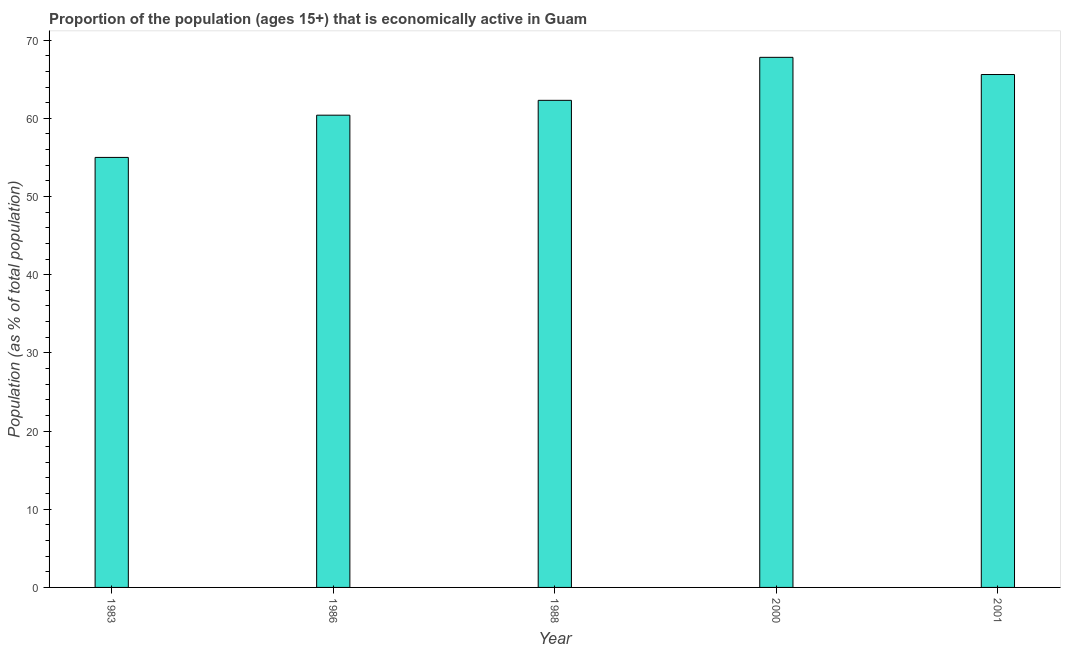Does the graph contain any zero values?
Your answer should be very brief. No. Does the graph contain grids?
Offer a very short reply. No. What is the title of the graph?
Offer a terse response. Proportion of the population (ages 15+) that is economically active in Guam. What is the label or title of the X-axis?
Provide a short and direct response. Year. What is the label or title of the Y-axis?
Provide a short and direct response. Population (as % of total population). What is the percentage of economically active population in 2001?
Provide a succinct answer. 65.6. Across all years, what is the maximum percentage of economically active population?
Ensure brevity in your answer.  67.8. In which year was the percentage of economically active population minimum?
Offer a terse response. 1983. What is the sum of the percentage of economically active population?
Your answer should be compact. 311.1. What is the difference between the percentage of economically active population in 2000 and 2001?
Offer a terse response. 2.2. What is the average percentage of economically active population per year?
Make the answer very short. 62.22. What is the median percentage of economically active population?
Your response must be concise. 62.3. Do a majority of the years between 2000 and 1988 (inclusive) have percentage of economically active population greater than 64 %?
Ensure brevity in your answer.  No. What is the ratio of the percentage of economically active population in 1983 to that in 2000?
Your answer should be compact. 0.81. What is the difference between the highest and the second highest percentage of economically active population?
Ensure brevity in your answer.  2.2. Is the sum of the percentage of economically active population in 2000 and 2001 greater than the maximum percentage of economically active population across all years?
Give a very brief answer. Yes. How many bars are there?
Offer a terse response. 5. Are all the bars in the graph horizontal?
Keep it short and to the point. No. Are the values on the major ticks of Y-axis written in scientific E-notation?
Ensure brevity in your answer.  No. What is the Population (as % of total population) in 1983?
Your response must be concise. 55. What is the Population (as % of total population) in 1986?
Your answer should be compact. 60.4. What is the Population (as % of total population) of 1988?
Offer a very short reply. 62.3. What is the Population (as % of total population) in 2000?
Offer a very short reply. 67.8. What is the Population (as % of total population) of 2001?
Keep it short and to the point. 65.6. What is the difference between the Population (as % of total population) in 1983 and 1986?
Your answer should be very brief. -5.4. What is the difference between the Population (as % of total population) in 1983 and 2000?
Provide a succinct answer. -12.8. What is the difference between the Population (as % of total population) in 1986 and 1988?
Your answer should be compact. -1.9. What is the difference between the Population (as % of total population) in 1986 and 2001?
Ensure brevity in your answer.  -5.2. What is the difference between the Population (as % of total population) in 1988 and 2000?
Keep it short and to the point. -5.5. What is the ratio of the Population (as % of total population) in 1983 to that in 1986?
Your answer should be very brief. 0.91. What is the ratio of the Population (as % of total population) in 1983 to that in 1988?
Your answer should be compact. 0.88. What is the ratio of the Population (as % of total population) in 1983 to that in 2000?
Give a very brief answer. 0.81. What is the ratio of the Population (as % of total population) in 1983 to that in 2001?
Offer a terse response. 0.84. What is the ratio of the Population (as % of total population) in 1986 to that in 2000?
Offer a terse response. 0.89. What is the ratio of the Population (as % of total population) in 1986 to that in 2001?
Keep it short and to the point. 0.92. What is the ratio of the Population (as % of total population) in 1988 to that in 2000?
Ensure brevity in your answer.  0.92. What is the ratio of the Population (as % of total population) in 1988 to that in 2001?
Offer a terse response. 0.95. What is the ratio of the Population (as % of total population) in 2000 to that in 2001?
Offer a very short reply. 1.03. 